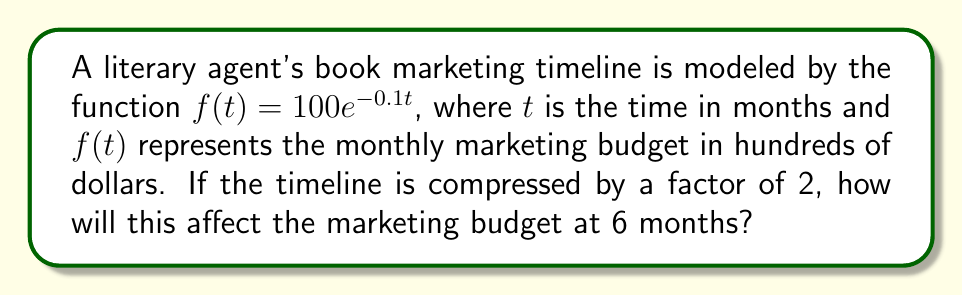What is the answer to this math problem? 1. The original function is $f(t) = 100e^{-0.1t}$.

2. Compressing the timeline by a factor of 2 means replacing $t$ with $2t$:
   $g(t) = 100e^{-0.1(2t)} = 100e^{-0.2t}$

3. To find the marketing budget at 6 months for the compressed timeline:
   $g(6) = 100e^{-0.2(6)} = 100e^{-1.2}$

4. Calculate this value:
   $g(6) = 100 \cdot (e^{-1.2}) \approx 30.12$

5. The original marketing budget at 6 months:
   $f(6) = 100e^{-0.1(6)} = 100e^{-0.6} \approx 54.88$

6. The difference:
   $54.88 - 30.12 = 24.76$

7. This represents a decrease of approximately $2,476 in the monthly marketing budget at the 6-month mark.
Answer: $2,476 decrease 